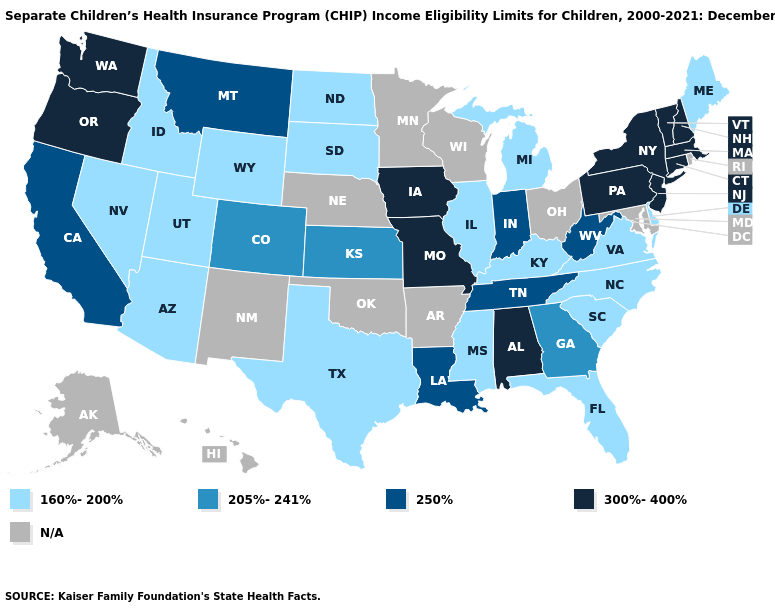What is the value of Vermont?
Short answer required. 300%-400%. Which states have the lowest value in the USA?
Quick response, please. Arizona, Delaware, Florida, Idaho, Illinois, Kentucky, Maine, Michigan, Mississippi, Nevada, North Carolina, North Dakota, South Carolina, South Dakota, Texas, Utah, Virginia, Wyoming. Name the states that have a value in the range 205%-241%?
Give a very brief answer. Colorado, Georgia, Kansas. What is the value of Iowa?
Concise answer only. 300%-400%. Does Texas have the lowest value in the USA?
Concise answer only. Yes. Does the first symbol in the legend represent the smallest category?
Keep it brief. Yes. What is the lowest value in the USA?
Keep it brief. 160%-200%. Among the states that border Louisiana , which have the highest value?
Answer briefly. Mississippi, Texas. What is the lowest value in the West?
Be succinct. 160%-200%. How many symbols are there in the legend?
Quick response, please. 5. What is the value of Illinois?
Short answer required. 160%-200%. What is the highest value in states that border Florida?
Keep it brief. 300%-400%. Name the states that have a value in the range 300%-400%?
Give a very brief answer. Alabama, Connecticut, Iowa, Massachusetts, Missouri, New Hampshire, New Jersey, New York, Oregon, Pennsylvania, Vermont, Washington. What is the value of Iowa?
Short answer required. 300%-400%. 